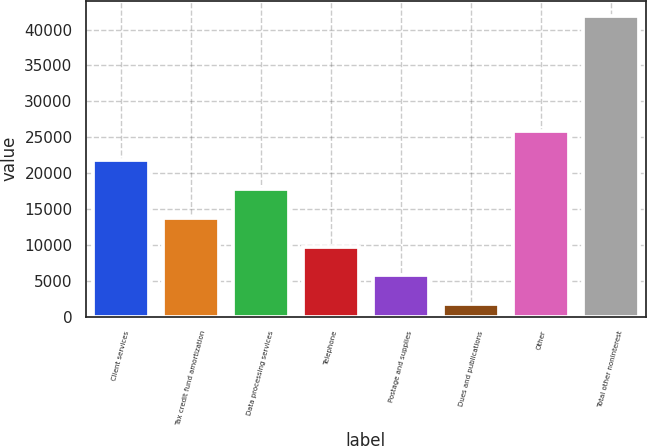<chart> <loc_0><loc_0><loc_500><loc_500><bar_chart><fcel>Client services<fcel>Tax credit fund amortization<fcel>Data processing services<fcel>Telephone<fcel>Postage and supplies<fcel>Dues and publications<fcel>Other<fcel>Total other noninterest<nl><fcel>21836<fcel>13799.6<fcel>17817.8<fcel>9781.4<fcel>5763.2<fcel>1745<fcel>25854.2<fcel>41927<nl></chart> 